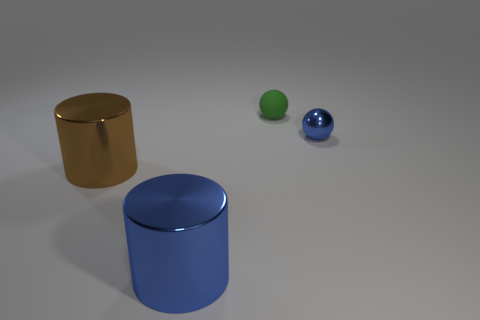Add 4 blue metallic cylinders. How many objects exist? 8 Subtract 0 brown blocks. How many objects are left? 4 Subtract all large brown cylinders. Subtract all small shiny things. How many objects are left? 2 Add 4 tiny blue spheres. How many tiny blue spheres are left? 5 Add 4 tiny green spheres. How many tiny green spheres exist? 5 